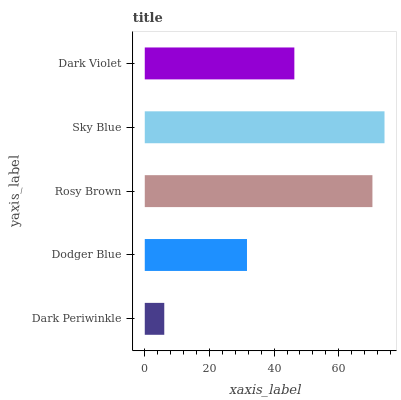Is Dark Periwinkle the minimum?
Answer yes or no. Yes. Is Sky Blue the maximum?
Answer yes or no. Yes. Is Dodger Blue the minimum?
Answer yes or no. No. Is Dodger Blue the maximum?
Answer yes or no. No. Is Dodger Blue greater than Dark Periwinkle?
Answer yes or no. Yes. Is Dark Periwinkle less than Dodger Blue?
Answer yes or no. Yes. Is Dark Periwinkle greater than Dodger Blue?
Answer yes or no. No. Is Dodger Blue less than Dark Periwinkle?
Answer yes or no. No. Is Dark Violet the high median?
Answer yes or no. Yes. Is Dark Violet the low median?
Answer yes or no. Yes. Is Rosy Brown the high median?
Answer yes or no. No. Is Rosy Brown the low median?
Answer yes or no. No. 